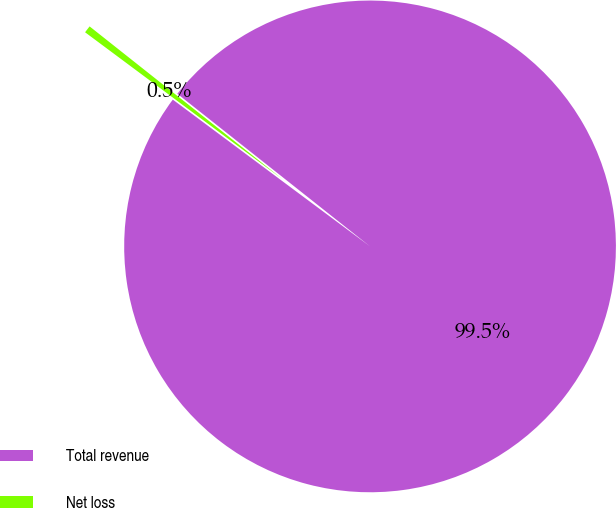Convert chart to OTSL. <chart><loc_0><loc_0><loc_500><loc_500><pie_chart><fcel>Total revenue<fcel>Net loss<nl><fcel>99.52%<fcel>0.48%<nl></chart> 